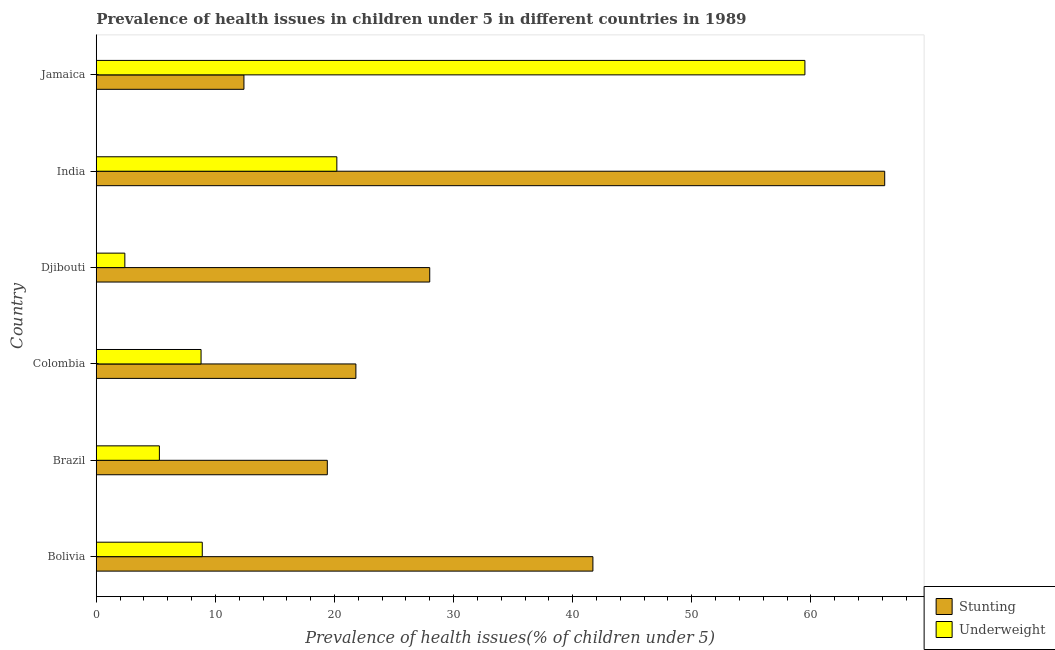How many different coloured bars are there?
Provide a succinct answer. 2. How many groups of bars are there?
Make the answer very short. 6. What is the percentage of stunted children in Jamaica?
Provide a succinct answer. 12.4. Across all countries, what is the maximum percentage of stunted children?
Your response must be concise. 66.2. Across all countries, what is the minimum percentage of stunted children?
Provide a succinct answer. 12.4. In which country was the percentage of underweight children maximum?
Keep it short and to the point. Jamaica. In which country was the percentage of stunted children minimum?
Your answer should be very brief. Jamaica. What is the total percentage of underweight children in the graph?
Your response must be concise. 105.1. What is the difference between the percentage of underweight children in Brazil and that in India?
Provide a short and direct response. -14.9. What is the difference between the percentage of underweight children in Bolivia and the percentage of stunted children in India?
Your answer should be compact. -57.3. What is the average percentage of underweight children per country?
Your answer should be compact. 17.52. What is the difference between the percentage of underweight children and percentage of stunted children in Bolivia?
Provide a succinct answer. -32.8. What is the ratio of the percentage of underweight children in Bolivia to that in Colombia?
Give a very brief answer. 1.01. Is the percentage of underweight children in Bolivia less than that in Colombia?
Your response must be concise. No. What is the difference between the highest and the second highest percentage of stunted children?
Keep it short and to the point. 24.5. What is the difference between the highest and the lowest percentage of stunted children?
Keep it short and to the point. 53.8. In how many countries, is the percentage of underweight children greater than the average percentage of underweight children taken over all countries?
Provide a short and direct response. 2. What does the 1st bar from the top in Bolivia represents?
Make the answer very short. Underweight. What does the 1st bar from the bottom in Djibouti represents?
Keep it short and to the point. Stunting. Are all the bars in the graph horizontal?
Give a very brief answer. Yes. Are the values on the major ticks of X-axis written in scientific E-notation?
Make the answer very short. No. Does the graph contain any zero values?
Your answer should be very brief. No. Does the graph contain grids?
Your response must be concise. No. Where does the legend appear in the graph?
Offer a terse response. Bottom right. How many legend labels are there?
Your answer should be very brief. 2. What is the title of the graph?
Provide a succinct answer. Prevalence of health issues in children under 5 in different countries in 1989. Does "Working only" appear as one of the legend labels in the graph?
Provide a succinct answer. No. What is the label or title of the X-axis?
Ensure brevity in your answer.  Prevalence of health issues(% of children under 5). What is the Prevalence of health issues(% of children under 5) in Stunting in Bolivia?
Offer a terse response. 41.7. What is the Prevalence of health issues(% of children under 5) in Underweight in Bolivia?
Your answer should be compact. 8.9. What is the Prevalence of health issues(% of children under 5) of Stunting in Brazil?
Your answer should be compact. 19.4. What is the Prevalence of health issues(% of children under 5) of Underweight in Brazil?
Ensure brevity in your answer.  5.3. What is the Prevalence of health issues(% of children under 5) of Stunting in Colombia?
Keep it short and to the point. 21.8. What is the Prevalence of health issues(% of children under 5) in Underweight in Colombia?
Provide a succinct answer. 8.8. What is the Prevalence of health issues(% of children under 5) in Underweight in Djibouti?
Your answer should be compact. 2.4. What is the Prevalence of health issues(% of children under 5) of Stunting in India?
Your answer should be very brief. 66.2. What is the Prevalence of health issues(% of children under 5) in Underweight in India?
Offer a very short reply. 20.2. What is the Prevalence of health issues(% of children under 5) in Stunting in Jamaica?
Provide a succinct answer. 12.4. What is the Prevalence of health issues(% of children under 5) of Underweight in Jamaica?
Provide a short and direct response. 59.5. Across all countries, what is the maximum Prevalence of health issues(% of children under 5) of Stunting?
Make the answer very short. 66.2. Across all countries, what is the maximum Prevalence of health issues(% of children under 5) in Underweight?
Your response must be concise. 59.5. Across all countries, what is the minimum Prevalence of health issues(% of children under 5) in Stunting?
Your response must be concise. 12.4. Across all countries, what is the minimum Prevalence of health issues(% of children under 5) in Underweight?
Provide a short and direct response. 2.4. What is the total Prevalence of health issues(% of children under 5) of Stunting in the graph?
Offer a terse response. 189.5. What is the total Prevalence of health issues(% of children under 5) in Underweight in the graph?
Offer a very short reply. 105.1. What is the difference between the Prevalence of health issues(% of children under 5) of Stunting in Bolivia and that in Brazil?
Offer a very short reply. 22.3. What is the difference between the Prevalence of health issues(% of children under 5) of Stunting in Bolivia and that in Colombia?
Your answer should be compact. 19.9. What is the difference between the Prevalence of health issues(% of children under 5) in Stunting in Bolivia and that in Djibouti?
Your answer should be compact. 13.7. What is the difference between the Prevalence of health issues(% of children under 5) in Stunting in Bolivia and that in India?
Your answer should be compact. -24.5. What is the difference between the Prevalence of health issues(% of children under 5) in Stunting in Bolivia and that in Jamaica?
Keep it short and to the point. 29.3. What is the difference between the Prevalence of health issues(% of children under 5) of Underweight in Bolivia and that in Jamaica?
Your response must be concise. -50.6. What is the difference between the Prevalence of health issues(% of children under 5) of Stunting in Brazil and that in Colombia?
Keep it short and to the point. -2.4. What is the difference between the Prevalence of health issues(% of children under 5) of Underweight in Brazil and that in Colombia?
Your answer should be compact. -3.5. What is the difference between the Prevalence of health issues(% of children under 5) in Stunting in Brazil and that in Djibouti?
Provide a short and direct response. -8.6. What is the difference between the Prevalence of health issues(% of children under 5) in Underweight in Brazil and that in Djibouti?
Make the answer very short. 2.9. What is the difference between the Prevalence of health issues(% of children under 5) in Stunting in Brazil and that in India?
Give a very brief answer. -46.8. What is the difference between the Prevalence of health issues(% of children under 5) in Underweight in Brazil and that in India?
Provide a succinct answer. -14.9. What is the difference between the Prevalence of health issues(% of children under 5) in Underweight in Brazil and that in Jamaica?
Keep it short and to the point. -54.2. What is the difference between the Prevalence of health issues(% of children under 5) of Stunting in Colombia and that in India?
Your response must be concise. -44.4. What is the difference between the Prevalence of health issues(% of children under 5) in Underweight in Colombia and that in India?
Offer a very short reply. -11.4. What is the difference between the Prevalence of health issues(% of children under 5) of Stunting in Colombia and that in Jamaica?
Give a very brief answer. 9.4. What is the difference between the Prevalence of health issues(% of children under 5) of Underweight in Colombia and that in Jamaica?
Provide a short and direct response. -50.7. What is the difference between the Prevalence of health issues(% of children under 5) in Stunting in Djibouti and that in India?
Your answer should be compact. -38.2. What is the difference between the Prevalence of health issues(% of children under 5) in Underweight in Djibouti and that in India?
Offer a very short reply. -17.8. What is the difference between the Prevalence of health issues(% of children under 5) of Underweight in Djibouti and that in Jamaica?
Offer a terse response. -57.1. What is the difference between the Prevalence of health issues(% of children under 5) in Stunting in India and that in Jamaica?
Provide a short and direct response. 53.8. What is the difference between the Prevalence of health issues(% of children under 5) of Underweight in India and that in Jamaica?
Your answer should be compact. -39.3. What is the difference between the Prevalence of health issues(% of children under 5) in Stunting in Bolivia and the Prevalence of health issues(% of children under 5) in Underweight in Brazil?
Keep it short and to the point. 36.4. What is the difference between the Prevalence of health issues(% of children under 5) of Stunting in Bolivia and the Prevalence of health issues(% of children under 5) of Underweight in Colombia?
Your response must be concise. 32.9. What is the difference between the Prevalence of health issues(% of children under 5) in Stunting in Bolivia and the Prevalence of health issues(% of children under 5) in Underweight in Djibouti?
Your response must be concise. 39.3. What is the difference between the Prevalence of health issues(% of children under 5) in Stunting in Bolivia and the Prevalence of health issues(% of children under 5) in Underweight in India?
Give a very brief answer. 21.5. What is the difference between the Prevalence of health issues(% of children under 5) in Stunting in Bolivia and the Prevalence of health issues(% of children under 5) in Underweight in Jamaica?
Your answer should be very brief. -17.8. What is the difference between the Prevalence of health issues(% of children under 5) of Stunting in Brazil and the Prevalence of health issues(% of children under 5) of Underweight in Jamaica?
Your response must be concise. -40.1. What is the difference between the Prevalence of health issues(% of children under 5) of Stunting in Colombia and the Prevalence of health issues(% of children under 5) of Underweight in Djibouti?
Offer a terse response. 19.4. What is the difference between the Prevalence of health issues(% of children under 5) in Stunting in Colombia and the Prevalence of health issues(% of children under 5) in Underweight in India?
Provide a succinct answer. 1.6. What is the difference between the Prevalence of health issues(% of children under 5) in Stunting in Colombia and the Prevalence of health issues(% of children under 5) in Underweight in Jamaica?
Make the answer very short. -37.7. What is the difference between the Prevalence of health issues(% of children under 5) in Stunting in Djibouti and the Prevalence of health issues(% of children under 5) in Underweight in Jamaica?
Ensure brevity in your answer.  -31.5. What is the average Prevalence of health issues(% of children under 5) of Stunting per country?
Ensure brevity in your answer.  31.58. What is the average Prevalence of health issues(% of children under 5) of Underweight per country?
Keep it short and to the point. 17.52. What is the difference between the Prevalence of health issues(% of children under 5) in Stunting and Prevalence of health issues(% of children under 5) in Underweight in Bolivia?
Offer a terse response. 32.8. What is the difference between the Prevalence of health issues(% of children under 5) of Stunting and Prevalence of health issues(% of children under 5) of Underweight in Colombia?
Your answer should be compact. 13. What is the difference between the Prevalence of health issues(% of children under 5) in Stunting and Prevalence of health issues(% of children under 5) in Underweight in Djibouti?
Provide a short and direct response. 25.6. What is the difference between the Prevalence of health issues(% of children under 5) in Stunting and Prevalence of health issues(% of children under 5) in Underweight in Jamaica?
Make the answer very short. -47.1. What is the ratio of the Prevalence of health issues(% of children under 5) in Stunting in Bolivia to that in Brazil?
Ensure brevity in your answer.  2.15. What is the ratio of the Prevalence of health issues(% of children under 5) of Underweight in Bolivia to that in Brazil?
Keep it short and to the point. 1.68. What is the ratio of the Prevalence of health issues(% of children under 5) of Stunting in Bolivia to that in Colombia?
Offer a terse response. 1.91. What is the ratio of the Prevalence of health issues(% of children under 5) in Underweight in Bolivia to that in Colombia?
Provide a short and direct response. 1.01. What is the ratio of the Prevalence of health issues(% of children under 5) of Stunting in Bolivia to that in Djibouti?
Give a very brief answer. 1.49. What is the ratio of the Prevalence of health issues(% of children under 5) of Underweight in Bolivia to that in Djibouti?
Keep it short and to the point. 3.71. What is the ratio of the Prevalence of health issues(% of children under 5) of Stunting in Bolivia to that in India?
Ensure brevity in your answer.  0.63. What is the ratio of the Prevalence of health issues(% of children under 5) of Underweight in Bolivia to that in India?
Give a very brief answer. 0.44. What is the ratio of the Prevalence of health issues(% of children under 5) in Stunting in Bolivia to that in Jamaica?
Provide a succinct answer. 3.36. What is the ratio of the Prevalence of health issues(% of children under 5) in Underweight in Bolivia to that in Jamaica?
Your answer should be compact. 0.15. What is the ratio of the Prevalence of health issues(% of children under 5) of Stunting in Brazil to that in Colombia?
Make the answer very short. 0.89. What is the ratio of the Prevalence of health issues(% of children under 5) in Underweight in Brazil to that in Colombia?
Offer a very short reply. 0.6. What is the ratio of the Prevalence of health issues(% of children under 5) in Stunting in Brazil to that in Djibouti?
Your answer should be compact. 0.69. What is the ratio of the Prevalence of health issues(% of children under 5) of Underweight in Brazil to that in Djibouti?
Your response must be concise. 2.21. What is the ratio of the Prevalence of health issues(% of children under 5) of Stunting in Brazil to that in India?
Offer a very short reply. 0.29. What is the ratio of the Prevalence of health issues(% of children under 5) of Underweight in Brazil to that in India?
Your answer should be very brief. 0.26. What is the ratio of the Prevalence of health issues(% of children under 5) of Stunting in Brazil to that in Jamaica?
Provide a short and direct response. 1.56. What is the ratio of the Prevalence of health issues(% of children under 5) in Underweight in Brazil to that in Jamaica?
Give a very brief answer. 0.09. What is the ratio of the Prevalence of health issues(% of children under 5) in Stunting in Colombia to that in Djibouti?
Provide a succinct answer. 0.78. What is the ratio of the Prevalence of health issues(% of children under 5) of Underweight in Colombia to that in Djibouti?
Provide a short and direct response. 3.67. What is the ratio of the Prevalence of health issues(% of children under 5) of Stunting in Colombia to that in India?
Provide a succinct answer. 0.33. What is the ratio of the Prevalence of health issues(% of children under 5) of Underweight in Colombia to that in India?
Ensure brevity in your answer.  0.44. What is the ratio of the Prevalence of health issues(% of children under 5) in Stunting in Colombia to that in Jamaica?
Offer a terse response. 1.76. What is the ratio of the Prevalence of health issues(% of children under 5) of Underweight in Colombia to that in Jamaica?
Offer a terse response. 0.15. What is the ratio of the Prevalence of health issues(% of children under 5) of Stunting in Djibouti to that in India?
Make the answer very short. 0.42. What is the ratio of the Prevalence of health issues(% of children under 5) of Underweight in Djibouti to that in India?
Provide a succinct answer. 0.12. What is the ratio of the Prevalence of health issues(% of children under 5) in Stunting in Djibouti to that in Jamaica?
Offer a very short reply. 2.26. What is the ratio of the Prevalence of health issues(% of children under 5) of Underweight in Djibouti to that in Jamaica?
Ensure brevity in your answer.  0.04. What is the ratio of the Prevalence of health issues(% of children under 5) in Stunting in India to that in Jamaica?
Keep it short and to the point. 5.34. What is the ratio of the Prevalence of health issues(% of children under 5) of Underweight in India to that in Jamaica?
Make the answer very short. 0.34. What is the difference between the highest and the second highest Prevalence of health issues(% of children under 5) in Underweight?
Ensure brevity in your answer.  39.3. What is the difference between the highest and the lowest Prevalence of health issues(% of children under 5) of Stunting?
Your answer should be very brief. 53.8. What is the difference between the highest and the lowest Prevalence of health issues(% of children under 5) of Underweight?
Provide a succinct answer. 57.1. 